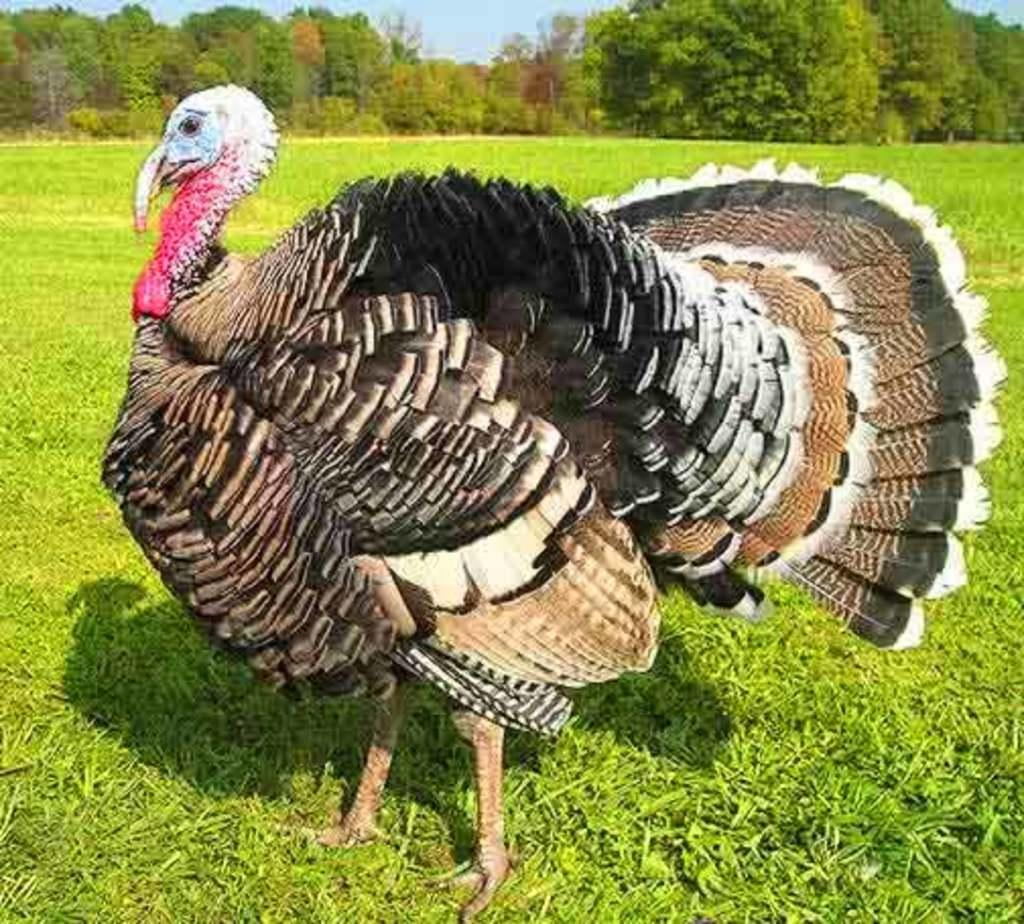What animal is present in the image? There is a turkey in the image. What is the turkey's position in relation to the ground? The turkey is standing on the ground. What type of vegetation covers the ground in the image? The ground is covered with grass. What can be seen in the background of the image? There are trees in the background of the image. How would you describe the sky in the image? The sky is clear and blue in the image. Can you tell me how the turkey is drinking water from the quicksand in the image? There is no quicksand or water present in the image, and the turkey is not shown drinking anything. 